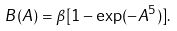<formula> <loc_0><loc_0><loc_500><loc_500>B ( A ) = \beta [ 1 - \exp ( - A ^ { 5 } ) ] .</formula> 